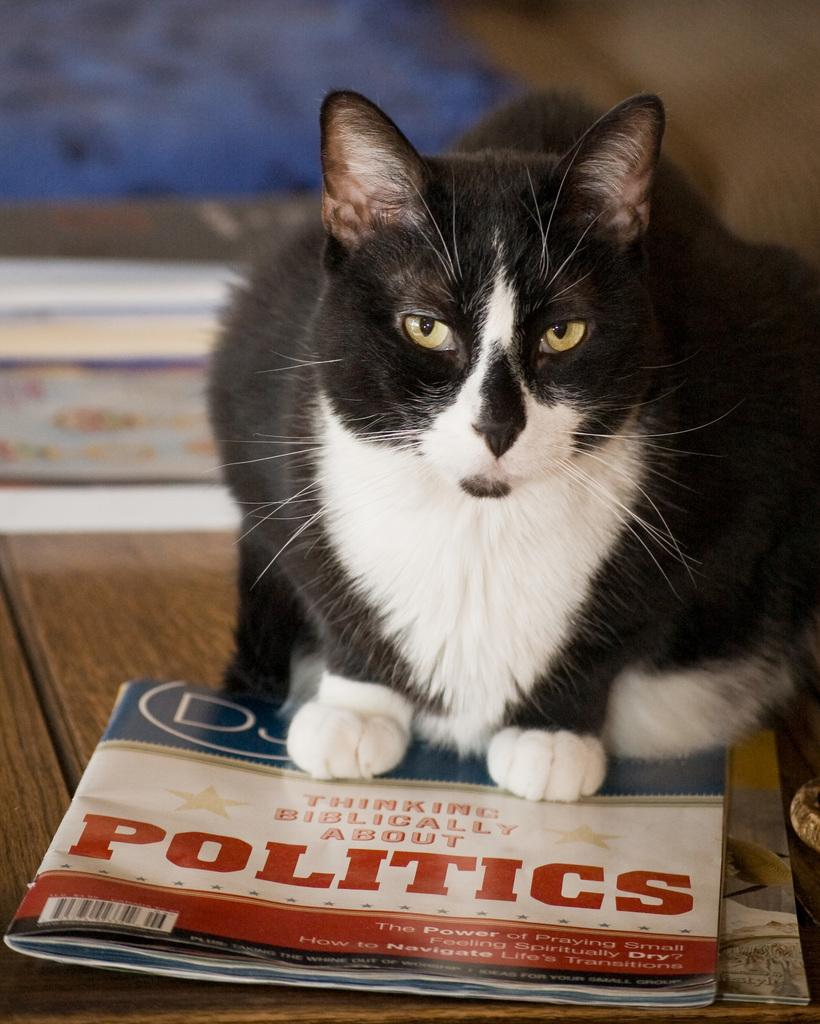<image>
Create a compact narrative representing the image presented. Black and White Cat standing on top of a magazine that says Politics. 